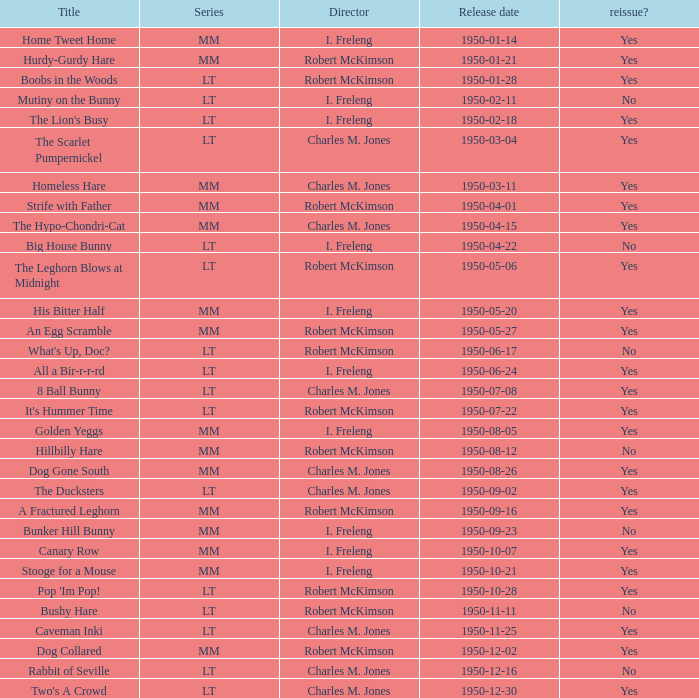Who directed Bunker Hill Bunny? I. Freleng. 